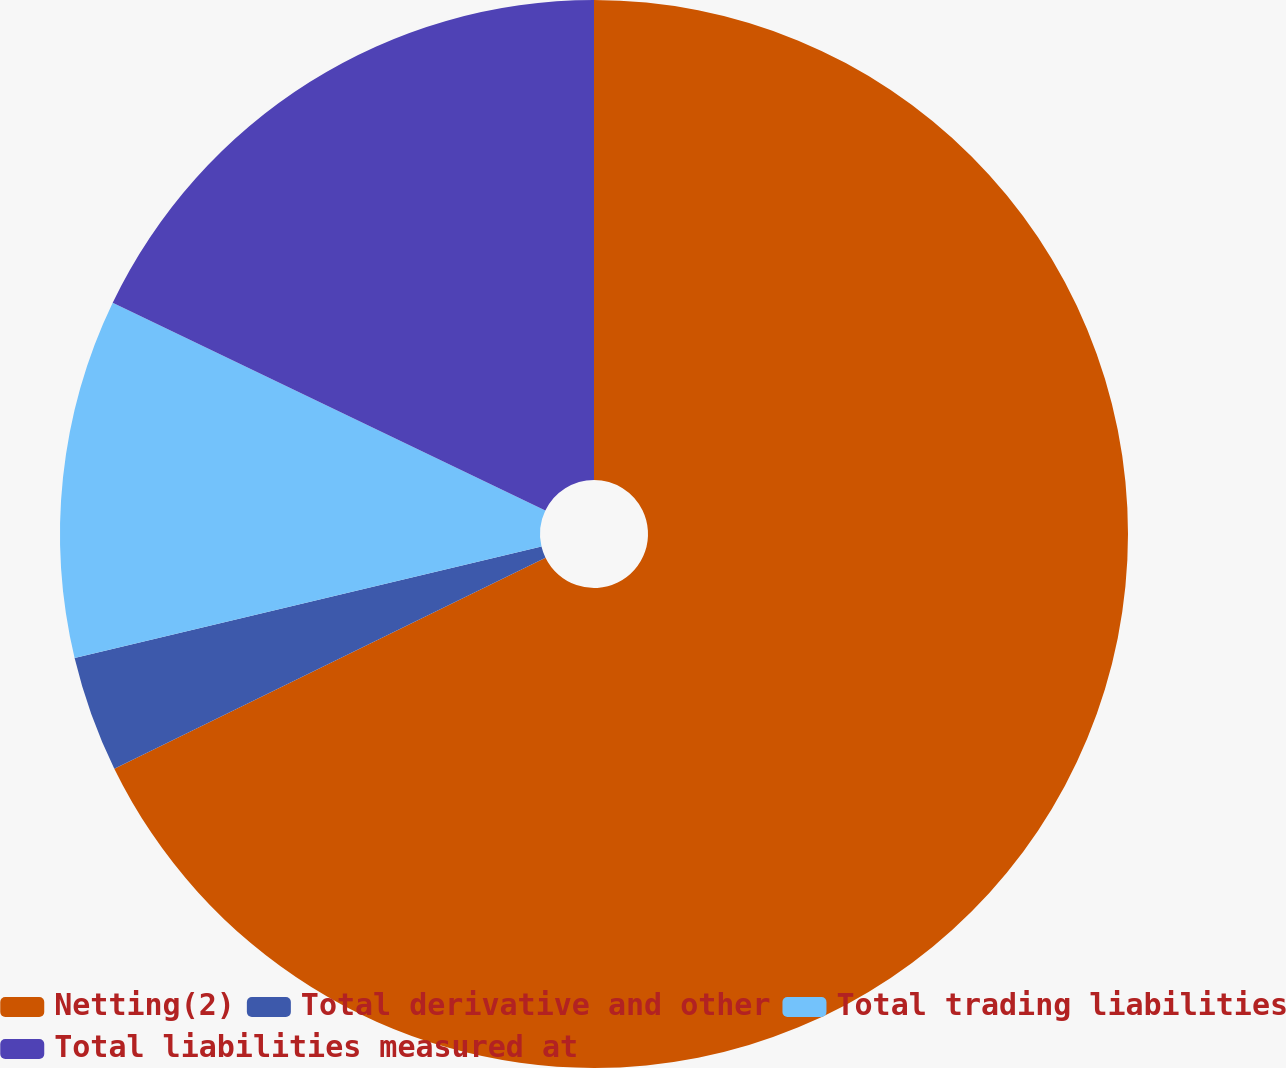<chart> <loc_0><loc_0><loc_500><loc_500><pie_chart><fcel>Netting(2)<fcel>Total derivative and other<fcel>Total trading liabilities<fcel>Total liabilities measured at<nl><fcel>67.76%<fcel>3.51%<fcel>10.86%<fcel>17.87%<nl></chart> 